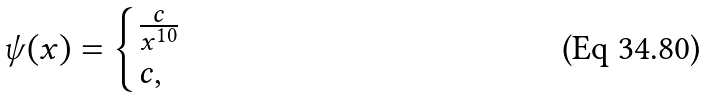Convert formula to latex. <formula><loc_0><loc_0><loc_500><loc_500>\psi ( x ) = \begin{cases} \frac { c } { x ^ { 1 0 } } & \\ c , & \end{cases}</formula> 